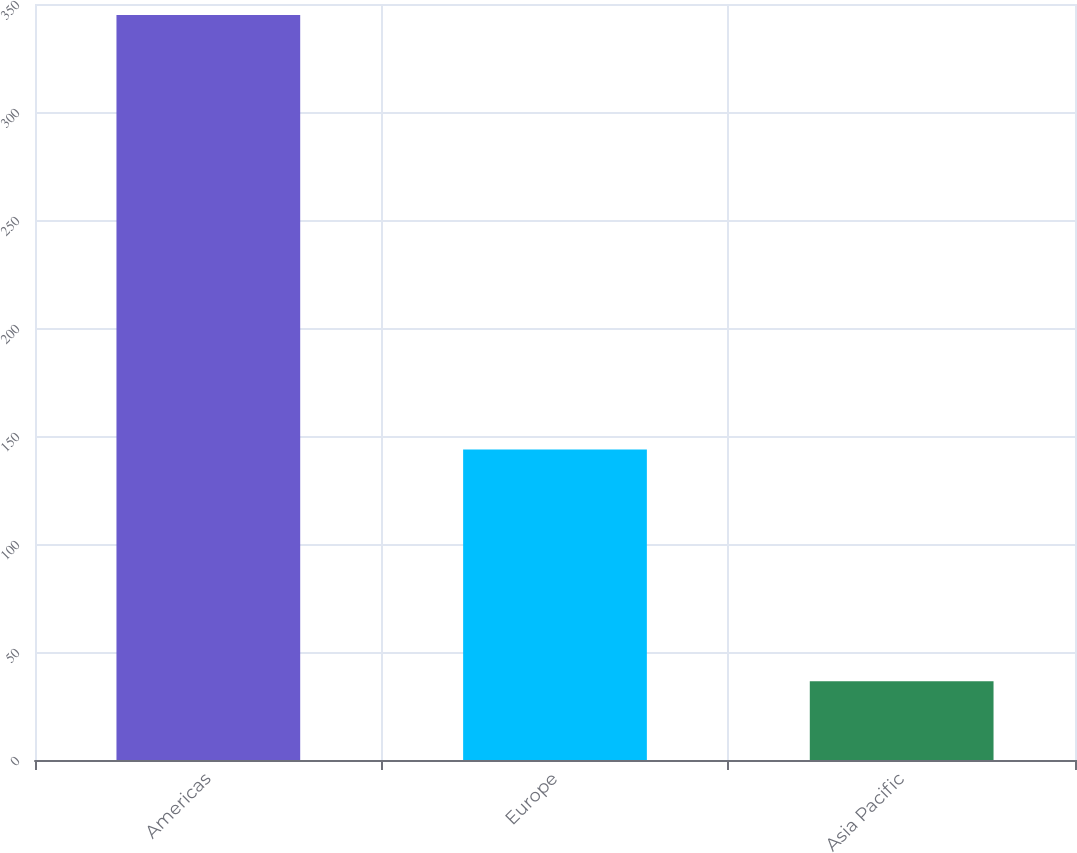Convert chart to OTSL. <chart><loc_0><loc_0><loc_500><loc_500><bar_chart><fcel>Americas<fcel>Europe<fcel>Asia Pacific<nl><fcel>344.9<fcel>143.8<fcel>36.5<nl></chart> 